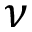Convert formula to latex. <formula><loc_0><loc_0><loc_500><loc_500>\nu</formula> 